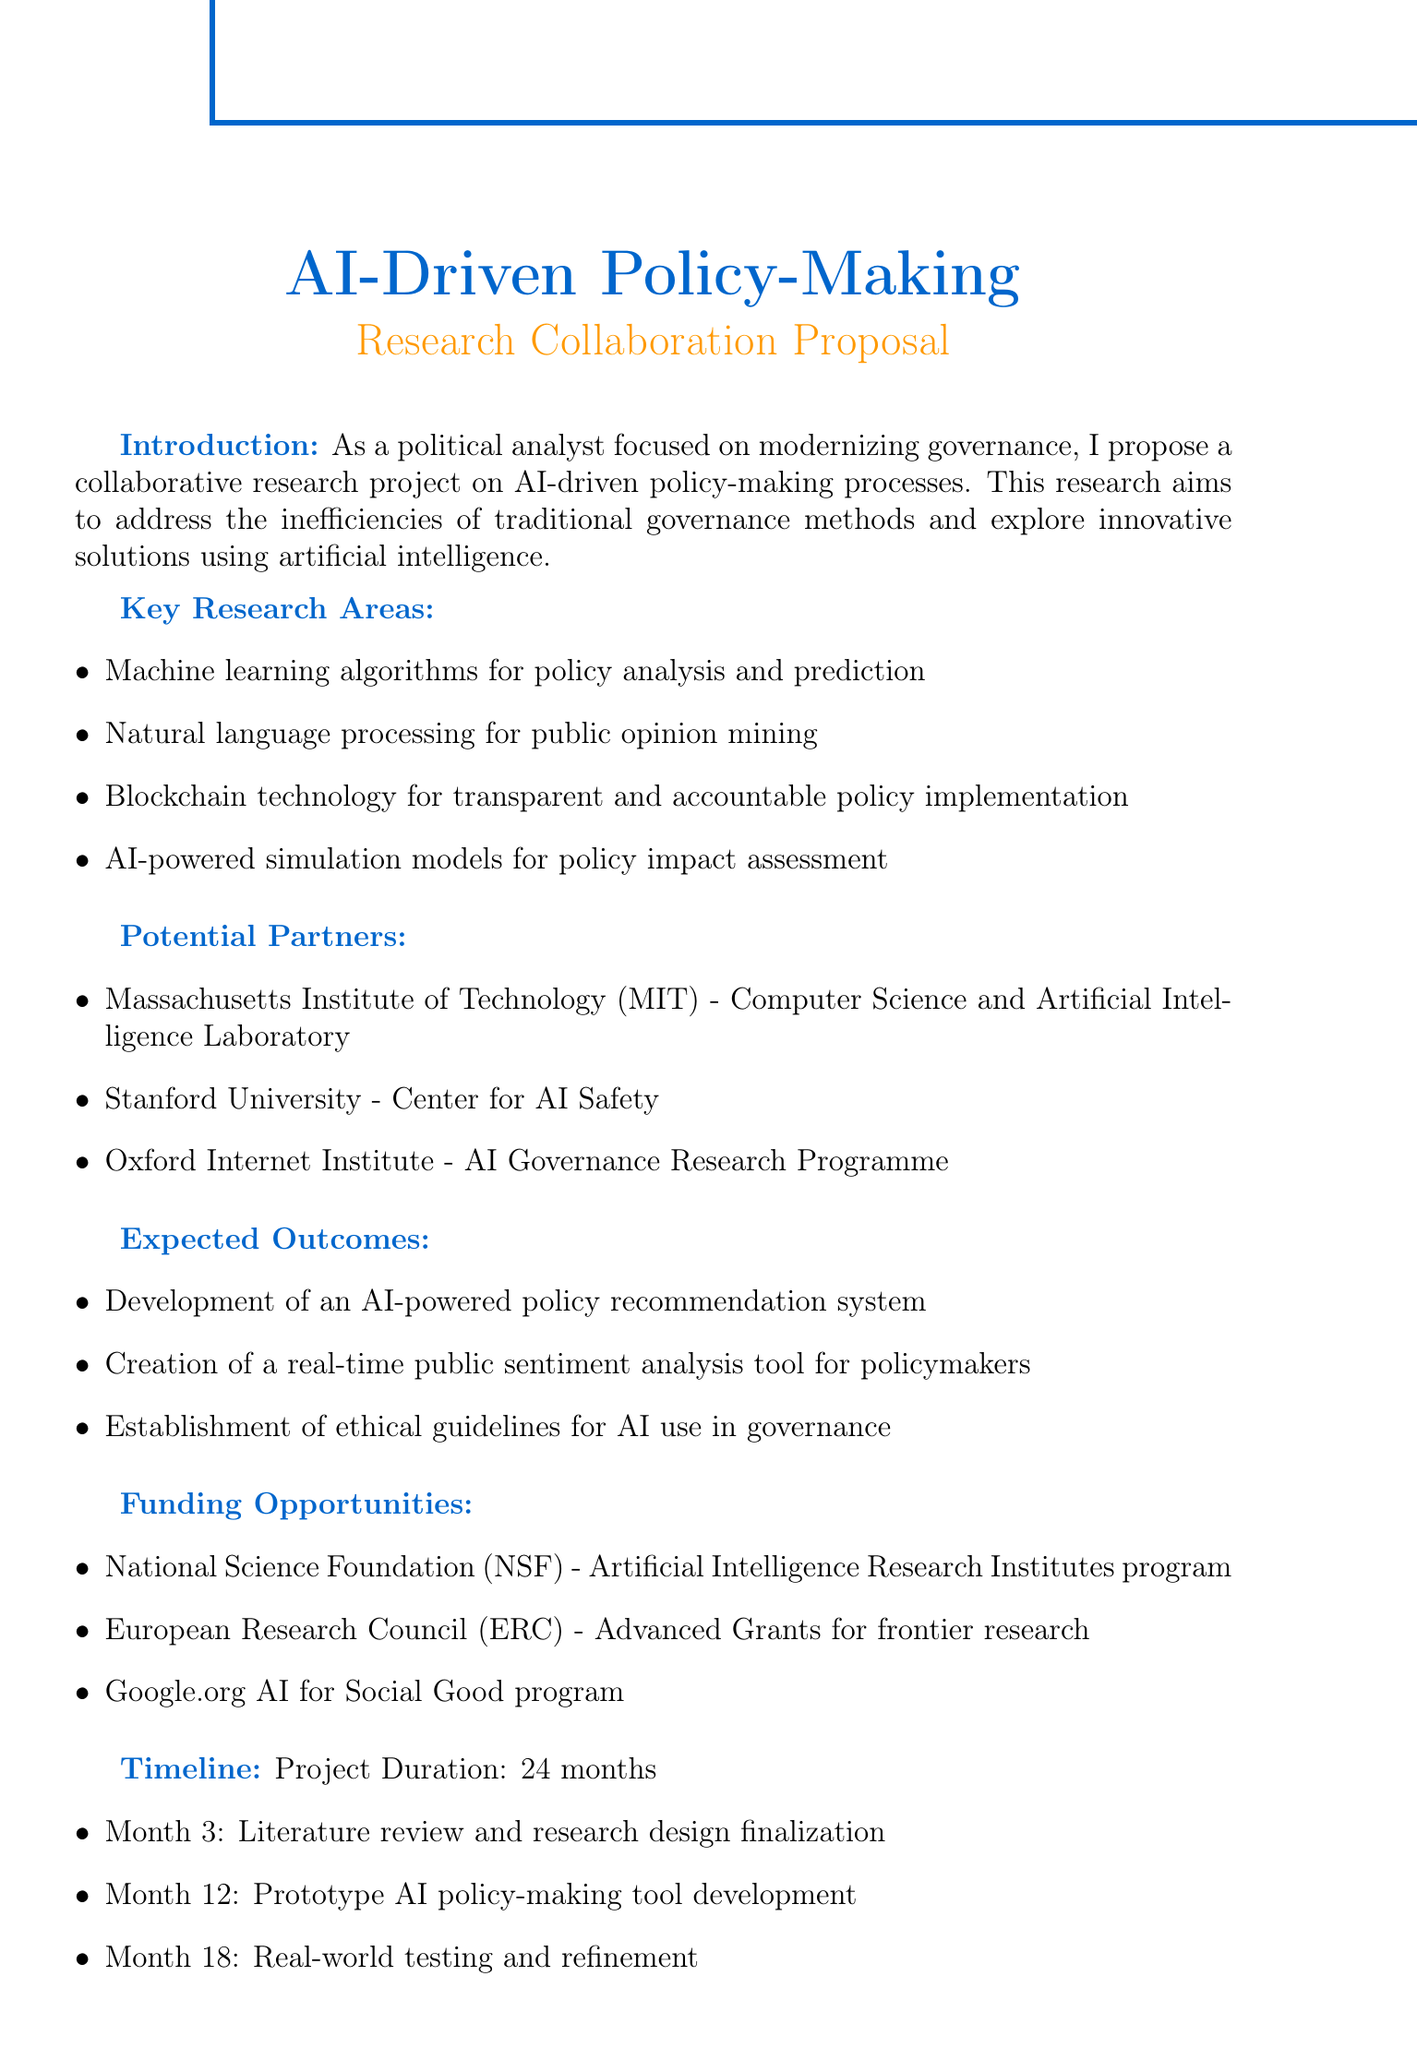What is the title of the proposal? The title of the proposal is explicitly stated at the top of the document.
Answer: AI-Driven Policy-Making Research Collaboration How long is the project duration? The project duration, clearly mentioned in the timeline section, offers a specific timeframe for the research.
Answer: 24 months Who is a potential partner from MIT? A specific organization is affiliated with MIT in the potential partners list provided in the document.
Answer: Computer Science and Artificial Intelligence Laboratory What is one expected outcome of the research? The document lists several outcomes, and one can be selected from those mentioned in the expected outcomes section.
Answer: Development of an AI-powered policy recommendation system When is the literature review and research design finalization scheduled? The timeline provides specific milestones, including the month for a particular task within the project duration.
Answer: Month 3 What technology is mentioned for transparent policy implementation? The document identifies a specific technology related to governance in the key research areas.
Answer: Blockchain technology What type of funding opportunity is mentioned from the European Research Council? The funding opportunities section details a specific program offered by the European Research Council.
Answer: Advanced Grants for frontier research What is the first milestone in the project timeline? The timeline outlines several key milestones; the first one can be directly referenced from it.
Answer: Month 3: Literature review and research design finalization What is the main goal of the research project? The introduction clearly states the principal aim addressed within the document’s context.
Answer: Address the inefficiencies of traditional governance methods 